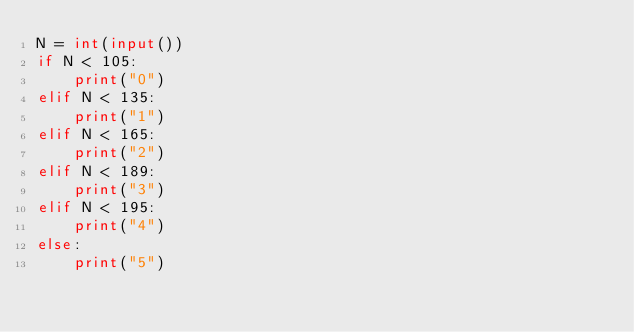Convert code to text. <code><loc_0><loc_0><loc_500><loc_500><_Python_>N = int(input())
if N < 105:
    print("0")
elif N < 135:
    print("1")
elif N < 165:
    print("2")
elif N < 189:
    print("3")
elif N < 195:
    print("4")
else:
    print("5")
</code> 